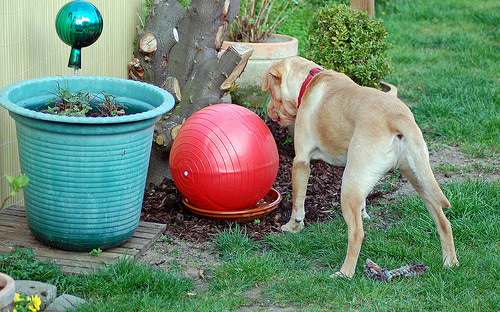<image>
Can you confirm if the ball is behind the dog? No. The ball is not behind the dog. From this viewpoint, the ball appears to be positioned elsewhere in the scene. 